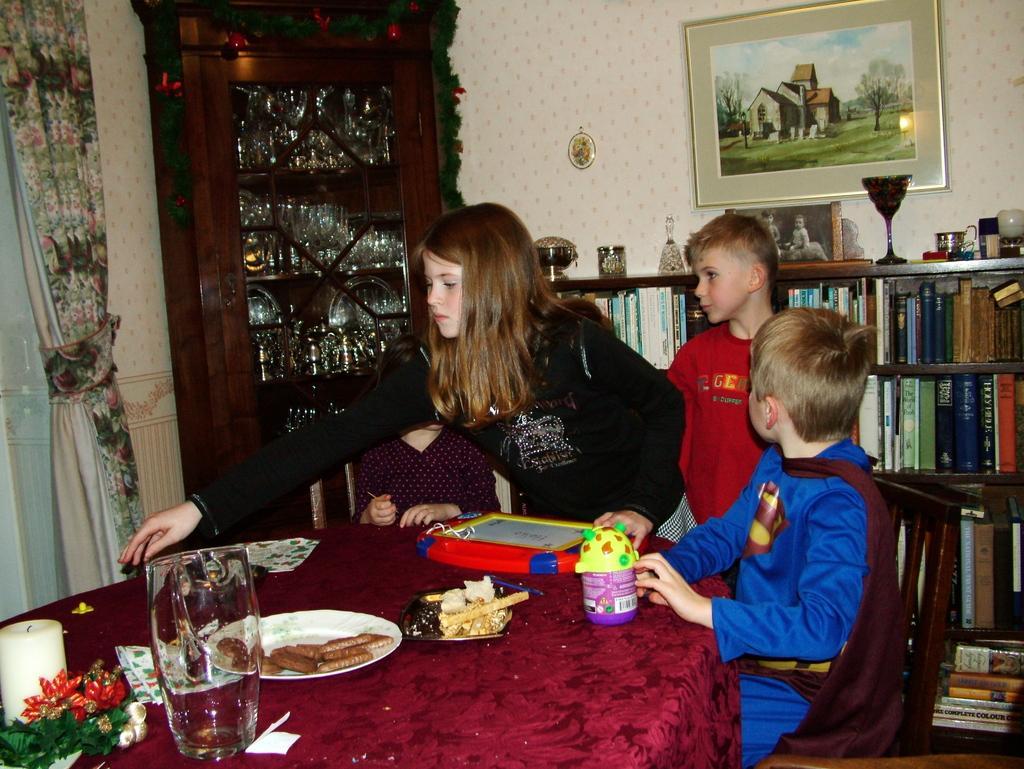How would you summarize this image in a sentence or two? In this image I can see a four children's. In front the child is wearing a superman costume and sitting on the chair. On the table there is a glass,plate,biscuits,bottle and a toy and there is a candle. The table is covered with a maroon cloth. At the back side there is a cupboard with some objects. The frame is on the wall there is a book rack and there is a curtain. The background is in white color. 